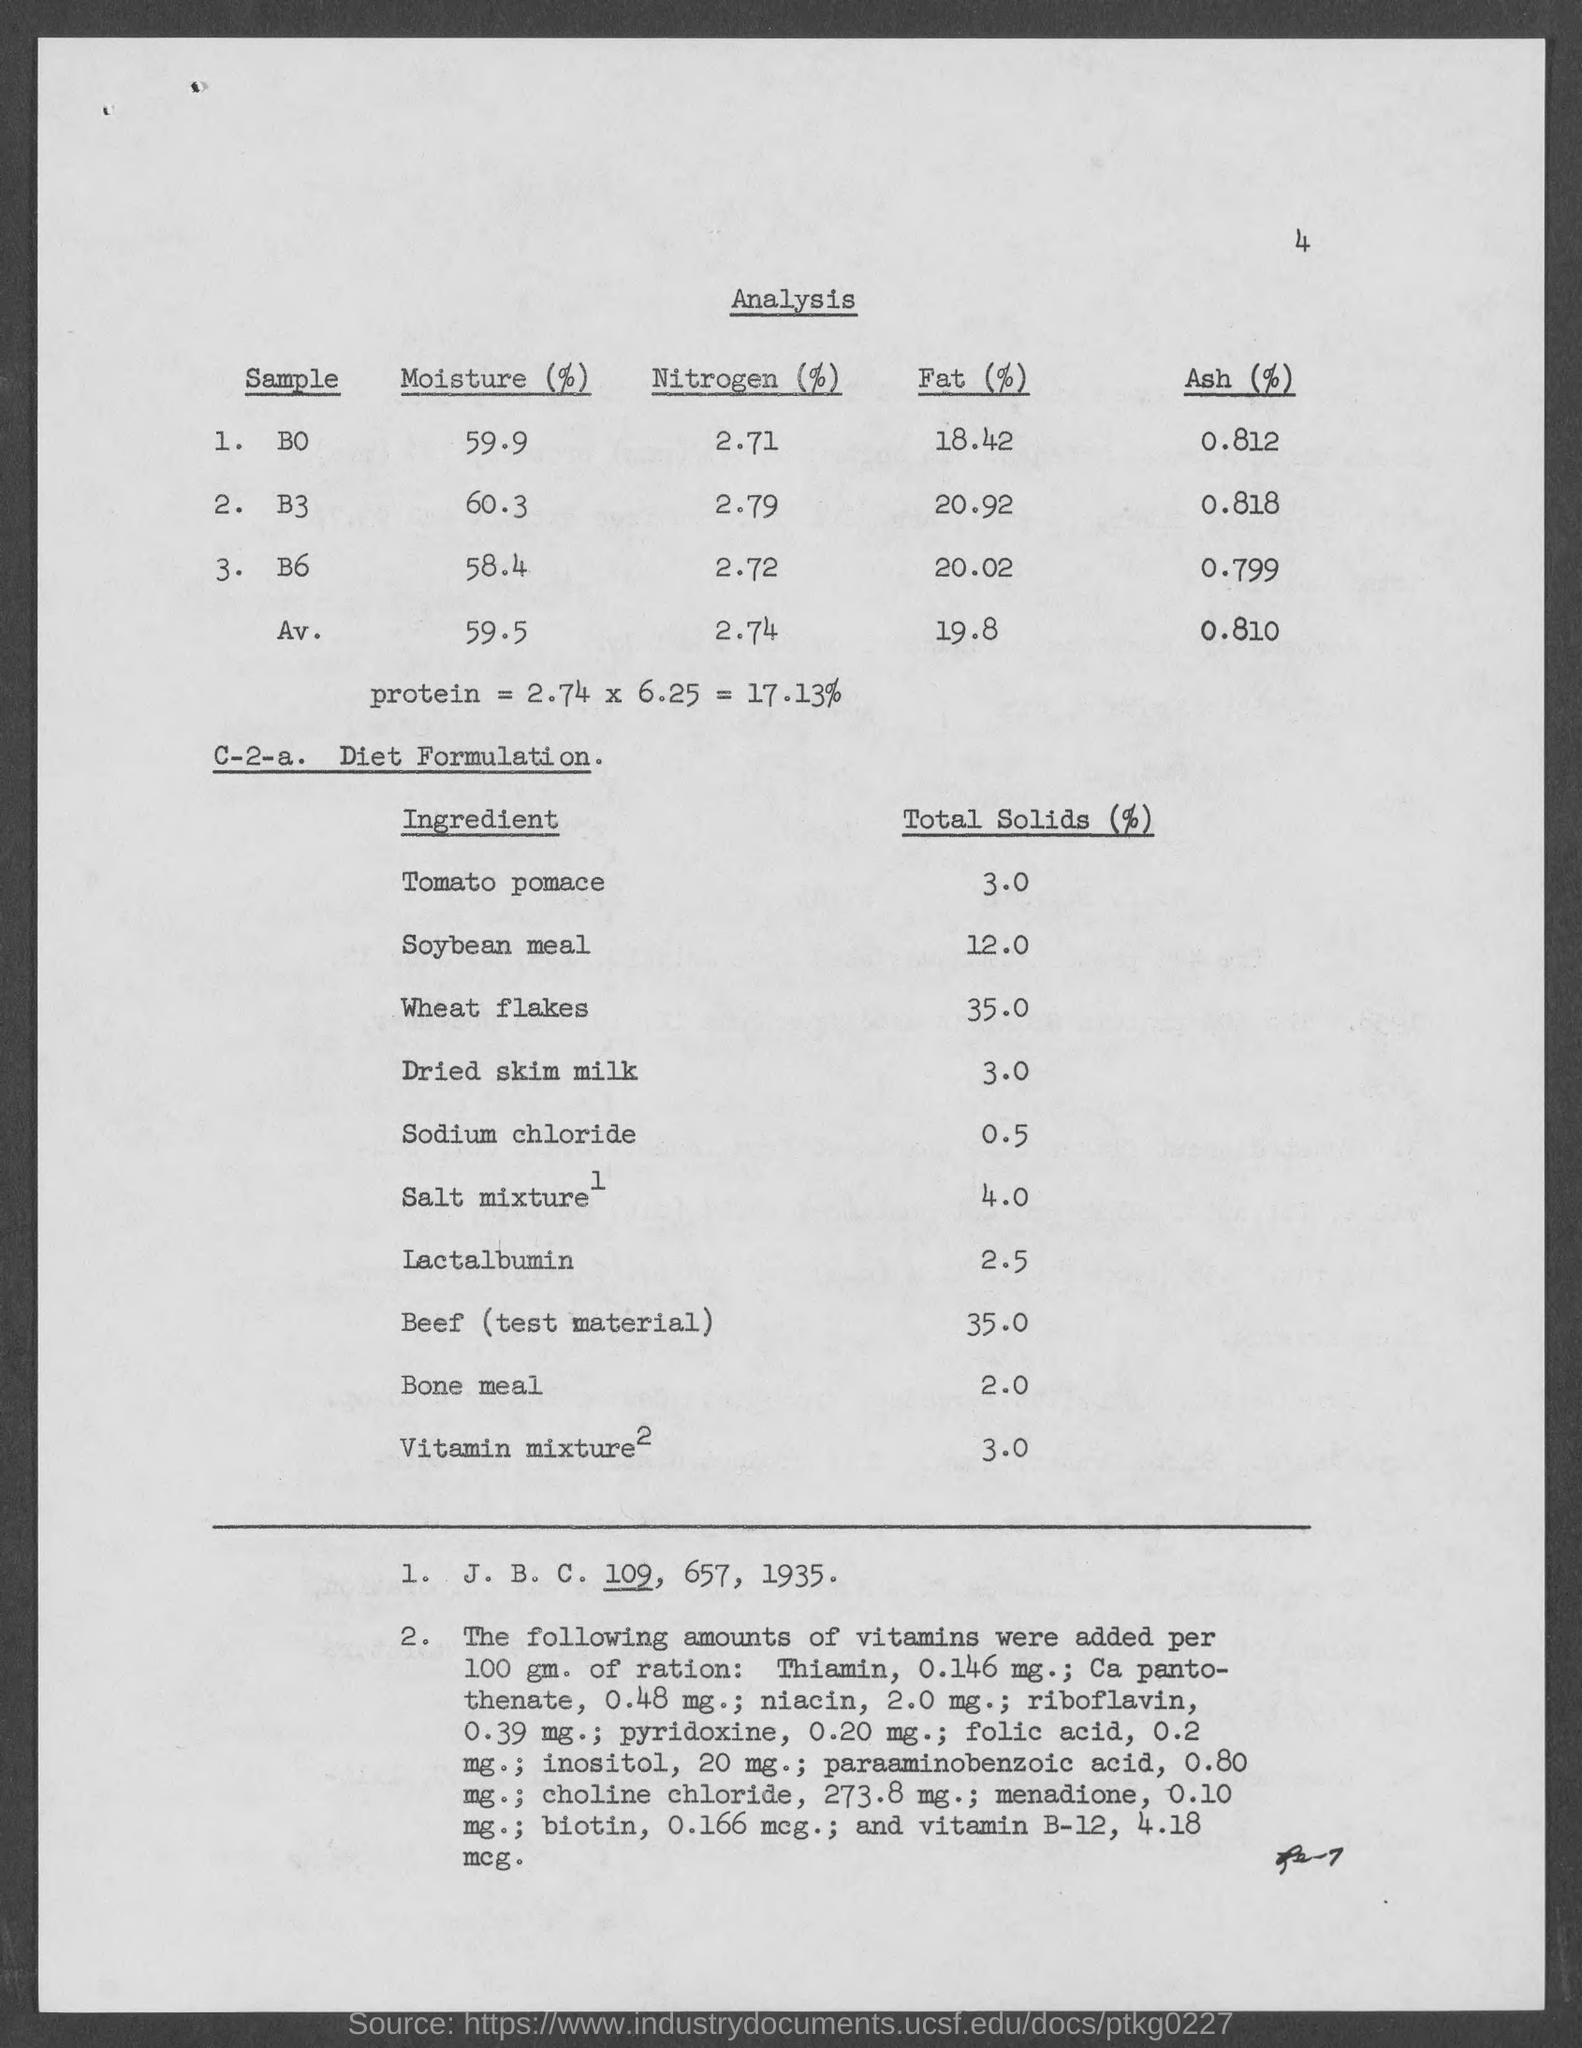What is the page no mentioned in this document?
Your answer should be compact. 4. What is the moisture (%) present in the sample B0 as per the analysis?
Offer a very short reply. 59.9. What is the nitrogen (%) present in the sample B3 as per the analysis?
Provide a short and direct response. 2.79. What is the Ash (%) present in the sample B0 as per the analysis?
Offer a terse response. .812. What is the Total Solids (%) in Soyabean meal given in the Diet Formulation?
Your answer should be very brief. 12.0. What is the Total Solids (%) in Wheat flakes given in the Diet Formulation?
Your answer should be very brief. 35.0. Which ingredient has the total solids (%) of 2.0 as given in the Diet Formulation?
Offer a terse response. Bone meal. What is the moisture (%) present in the sample B6 as per the analysis?
Make the answer very short. 58.4. 